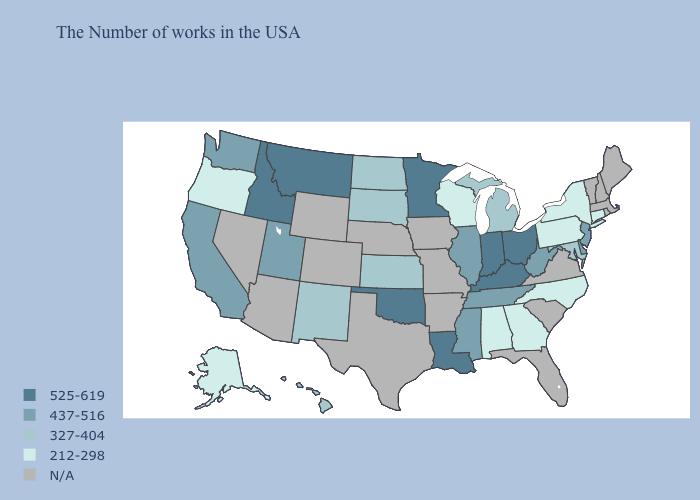Does New York have the highest value in the Northeast?
Concise answer only. No. Among the states that border New York , does Connecticut have the highest value?
Concise answer only. No. How many symbols are there in the legend?
Give a very brief answer. 5. Does the map have missing data?
Keep it brief. Yes. Among the states that border Maryland , which have the highest value?
Be succinct. Delaware, West Virginia. What is the value of New Hampshire?
Keep it brief. N/A. Does the map have missing data?
Concise answer only. Yes. What is the value of Idaho?
Give a very brief answer. 525-619. Does the first symbol in the legend represent the smallest category?
Give a very brief answer. No. Does the first symbol in the legend represent the smallest category?
Give a very brief answer. No. Does California have the lowest value in the USA?
Answer briefly. No. Name the states that have a value in the range 437-516?
Keep it brief. New Jersey, Delaware, West Virginia, Tennessee, Illinois, Mississippi, Utah, California, Washington. Which states have the lowest value in the USA?
Be succinct. Connecticut, New York, Pennsylvania, North Carolina, Georgia, Alabama, Wisconsin, Oregon, Alaska. 